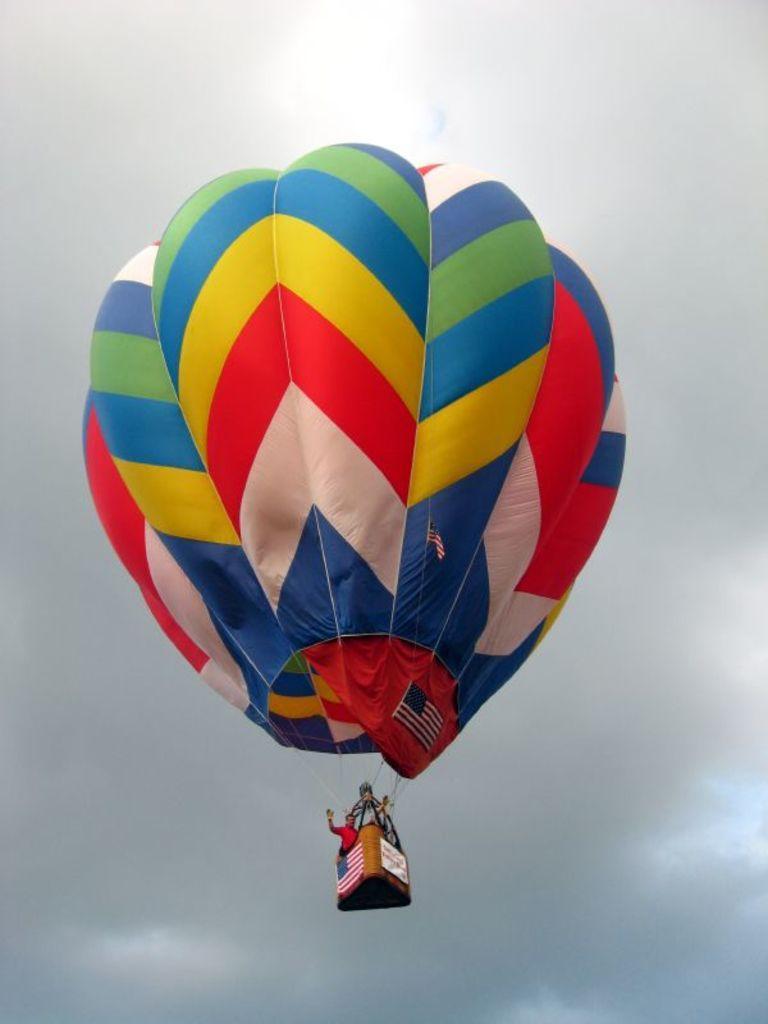Please provide a concise description of this image. In this image we can see one hot air balloon in the sky, two person´s in the hot air balloon basket, two flags attached to the hot air balloon, one flag and one banner attached to the hot air balloon basket. In the background there is the cloudy sky. 